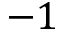<formula> <loc_0><loc_0><loc_500><loc_500>- 1</formula> 